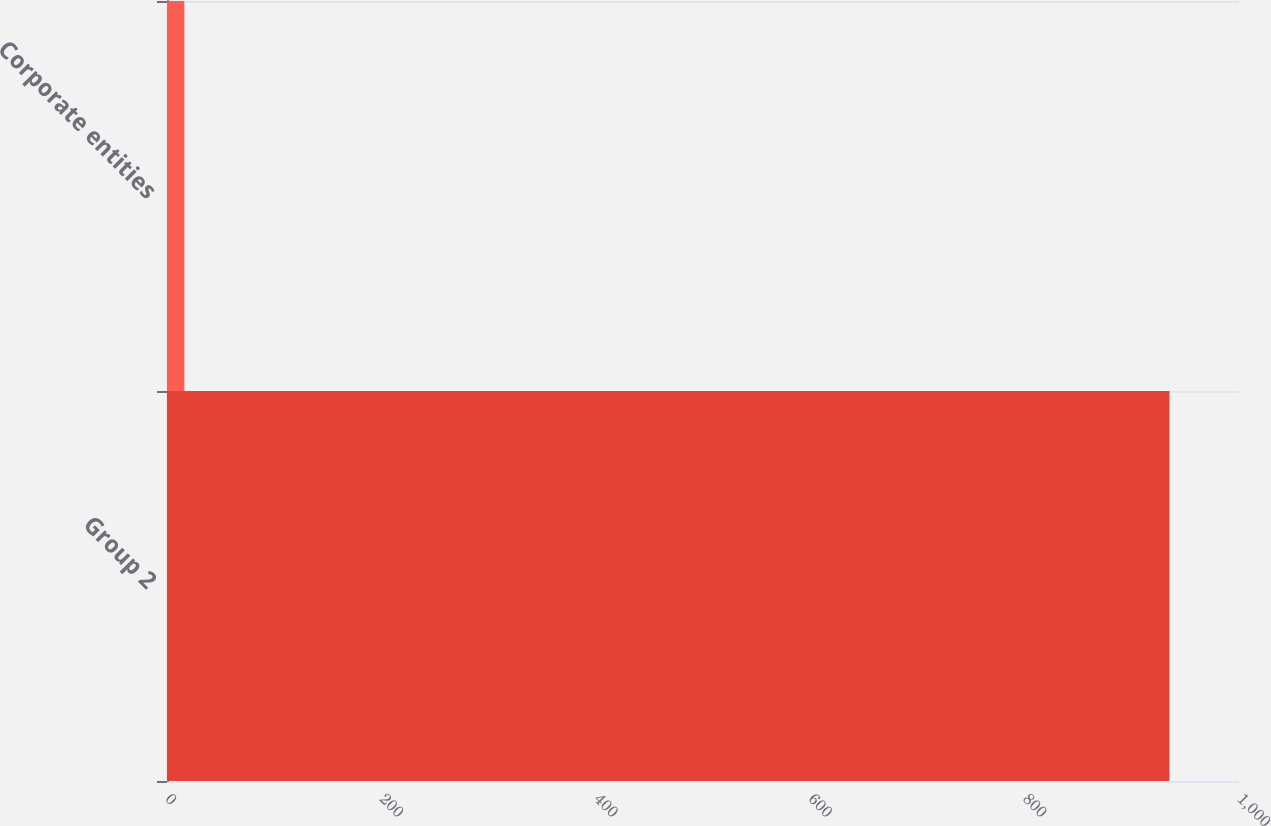<chart> <loc_0><loc_0><loc_500><loc_500><bar_chart><fcel>Group 2<fcel>Corporate entities<nl><fcel>935.2<fcel>16.2<nl></chart> 